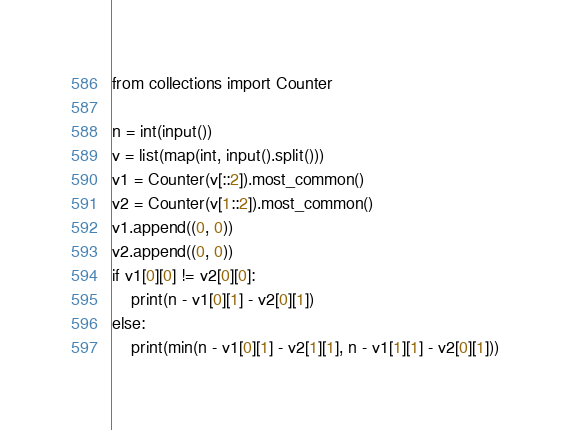<code> <loc_0><loc_0><loc_500><loc_500><_Python_>from collections import Counter

n = int(input())
v = list(map(int, input().split()))
v1 = Counter(v[::2]).most_common()
v2 = Counter(v[1::2]).most_common()
v1.append((0, 0))
v2.append((0, 0))
if v1[0][0] != v2[0][0]:
    print(n - v1[0][1] - v2[0][1])
else:
    print(min(n - v1[0][1] - v2[1][1], n - v1[1][1] - v2[0][1]))</code> 